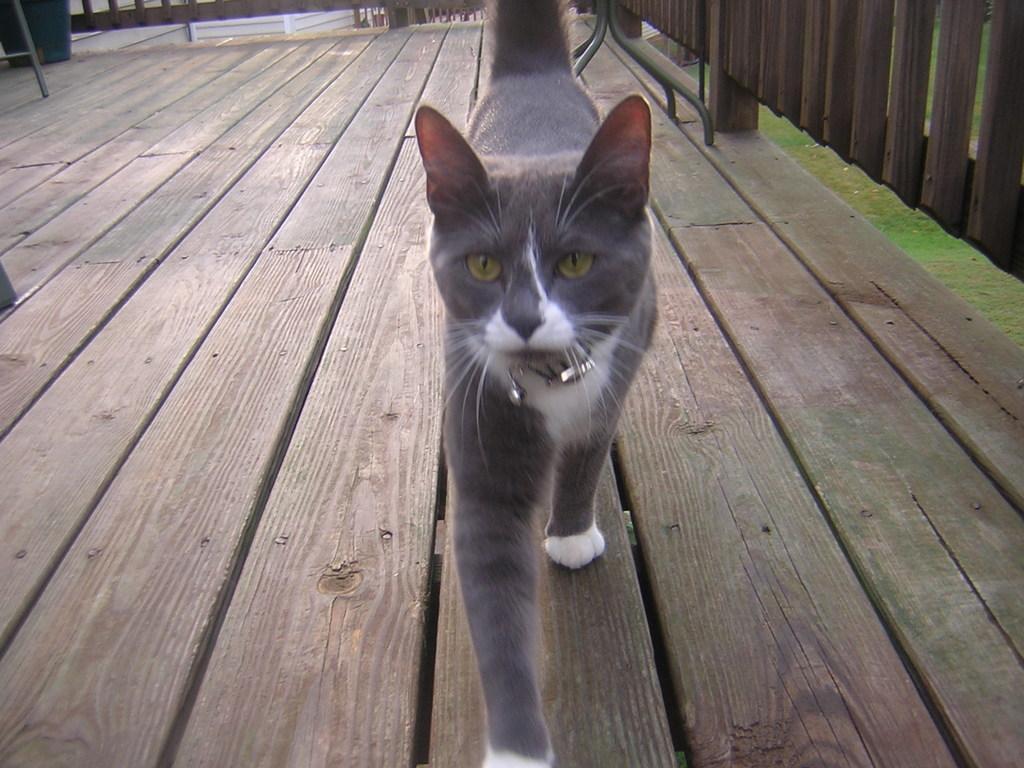How would you summarize this image in a sentence or two? In this image I can see a cat walking on the wooden path. Cat is in ash and white color. Back I can see a fencing and green grass. 